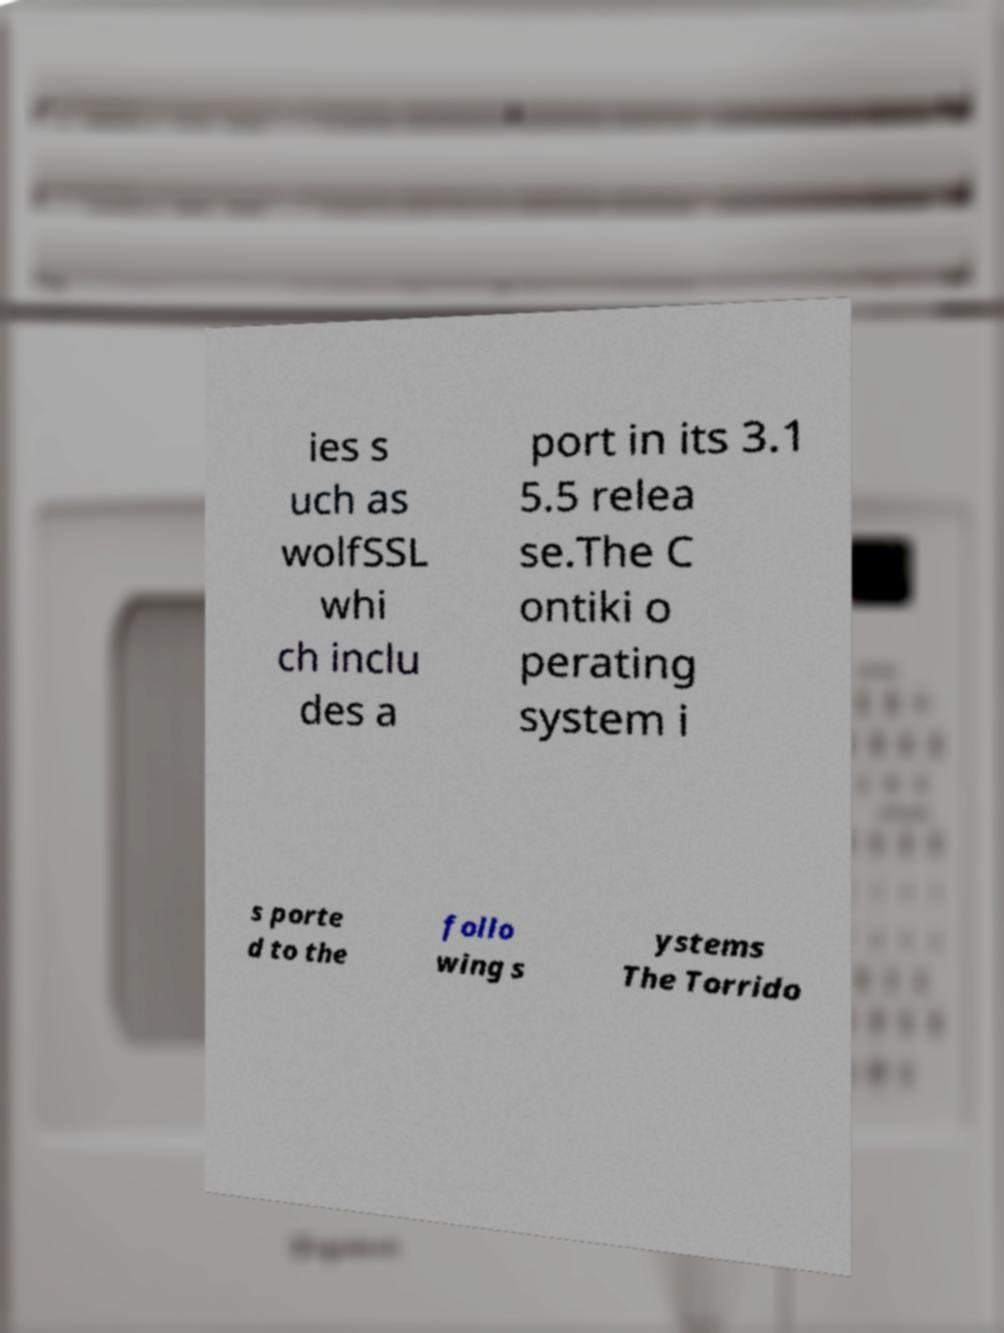For documentation purposes, I need the text within this image transcribed. Could you provide that? ies s uch as wolfSSL whi ch inclu des a port in its 3.1 5.5 relea se.The C ontiki o perating system i s porte d to the follo wing s ystems The Torrido 